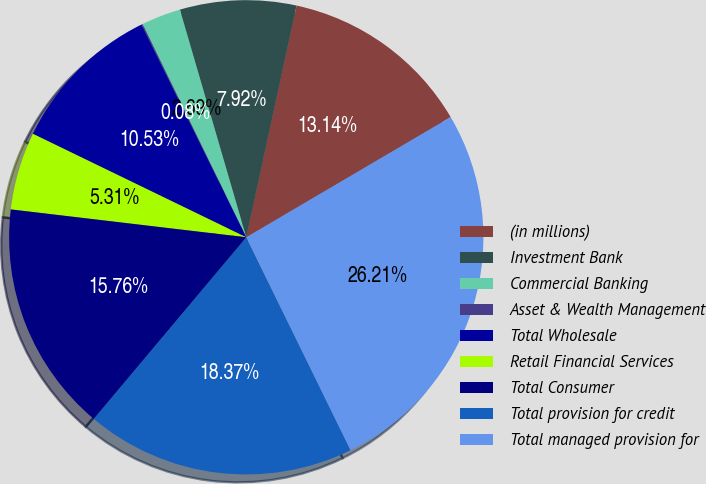<chart> <loc_0><loc_0><loc_500><loc_500><pie_chart><fcel>(in millions)<fcel>Investment Bank<fcel>Commercial Banking<fcel>Asset & Wealth Management<fcel>Total Wholesale<fcel>Retail Financial Services<fcel>Total Consumer<fcel>Total provision for credit<fcel>Total managed provision for<nl><fcel>13.14%<fcel>7.92%<fcel>2.69%<fcel>0.08%<fcel>10.53%<fcel>5.31%<fcel>15.76%<fcel>18.37%<fcel>26.21%<nl></chart> 